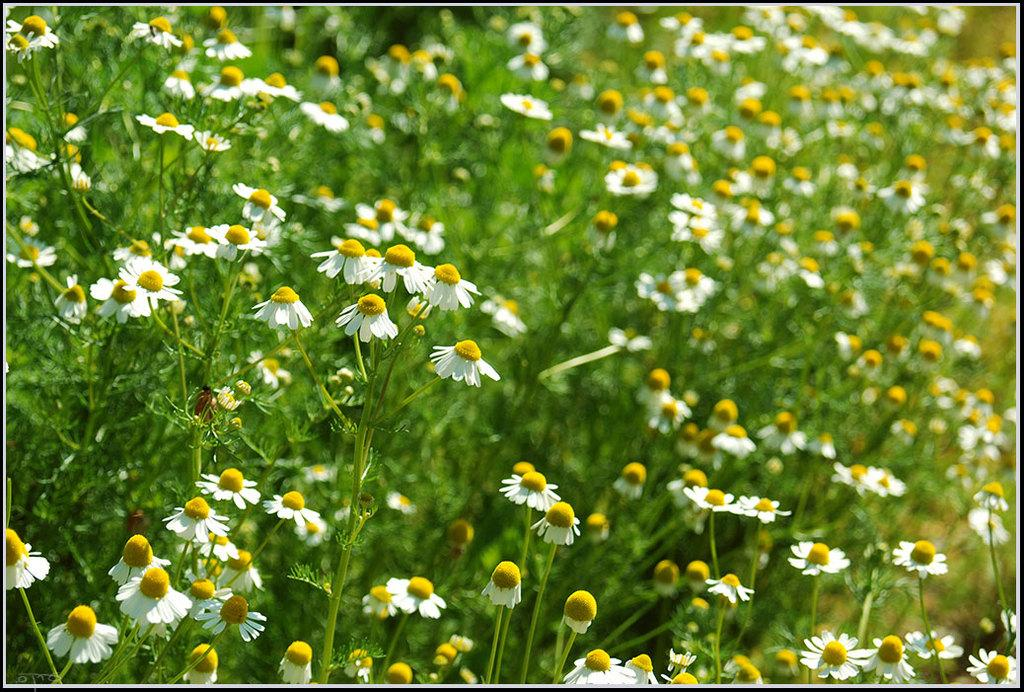What is the main subject of the image? The main subject of the image is a field of flowers. Can you describe the flowers in the field? Unfortunately, the facts provided do not give any details about the flowers in the field. What might be the season or time of day based on the image? The facts provided do not give any information about the season or time of day. What type of organization is responsible for maintaining the sugar production in the field? There is no mention of sugar production or any organization in the image or the provided facts. 